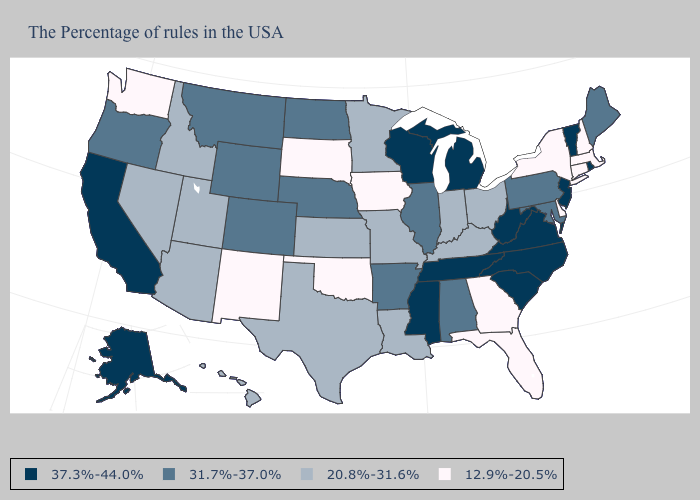Name the states that have a value in the range 12.9%-20.5%?
Keep it brief. Massachusetts, New Hampshire, Connecticut, New York, Delaware, Florida, Georgia, Iowa, Oklahoma, South Dakota, New Mexico, Washington. Which states hav the highest value in the Northeast?
Write a very short answer. Rhode Island, Vermont, New Jersey. Does New Hampshire have a lower value than Illinois?
Keep it brief. Yes. What is the value of Georgia?
Quick response, please. 12.9%-20.5%. Which states have the highest value in the USA?
Short answer required. Rhode Island, Vermont, New Jersey, Virginia, North Carolina, South Carolina, West Virginia, Michigan, Tennessee, Wisconsin, Mississippi, California, Alaska. Does Wisconsin have the highest value in the MidWest?
Be succinct. Yes. Name the states that have a value in the range 31.7%-37.0%?
Quick response, please. Maine, Maryland, Pennsylvania, Alabama, Illinois, Arkansas, Nebraska, North Dakota, Wyoming, Colorado, Montana, Oregon. Which states hav the highest value in the Northeast?
Answer briefly. Rhode Island, Vermont, New Jersey. What is the value of Oregon?
Answer briefly. 31.7%-37.0%. What is the value of South Dakota?
Quick response, please. 12.9%-20.5%. Name the states that have a value in the range 37.3%-44.0%?
Short answer required. Rhode Island, Vermont, New Jersey, Virginia, North Carolina, South Carolina, West Virginia, Michigan, Tennessee, Wisconsin, Mississippi, California, Alaska. Name the states that have a value in the range 12.9%-20.5%?
Answer briefly. Massachusetts, New Hampshire, Connecticut, New York, Delaware, Florida, Georgia, Iowa, Oklahoma, South Dakota, New Mexico, Washington. What is the value of South Dakota?
Quick response, please. 12.9%-20.5%. Name the states that have a value in the range 31.7%-37.0%?
Answer briefly. Maine, Maryland, Pennsylvania, Alabama, Illinois, Arkansas, Nebraska, North Dakota, Wyoming, Colorado, Montana, Oregon. Does Colorado have the highest value in the USA?
Write a very short answer. No. 